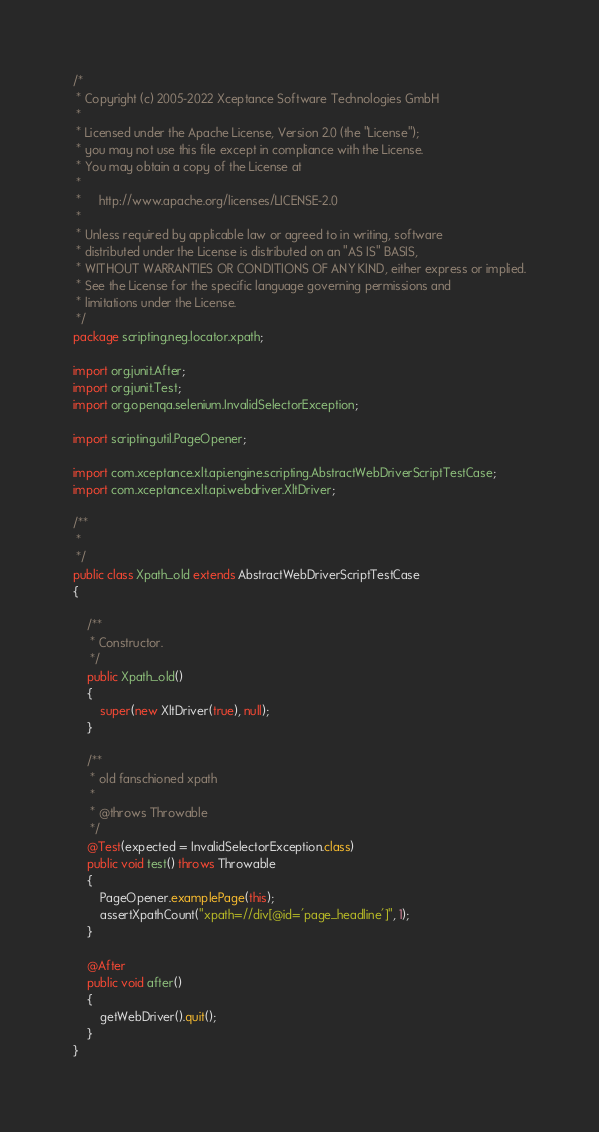<code> <loc_0><loc_0><loc_500><loc_500><_Java_>/*
 * Copyright (c) 2005-2022 Xceptance Software Technologies GmbH
 *
 * Licensed under the Apache License, Version 2.0 (the "License");
 * you may not use this file except in compliance with the License.
 * You may obtain a copy of the License at
 *
 *     http://www.apache.org/licenses/LICENSE-2.0
 *
 * Unless required by applicable law or agreed to in writing, software
 * distributed under the License is distributed on an "AS IS" BASIS,
 * WITHOUT WARRANTIES OR CONDITIONS OF ANY KIND, either express or implied.
 * See the License for the specific language governing permissions and
 * limitations under the License.
 */
package scripting.neg.locator.xpath;

import org.junit.After;
import org.junit.Test;
import org.openqa.selenium.InvalidSelectorException;

import scripting.util.PageOpener;

import com.xceptance.xlt.api.engine.scripting.AbstractWebDriverScriptTestCase;
import com.xceptance.xlt.api.webdriver.XltDriver;

/**
 * 
 */
public class Xpath_old extends AbstractWebDriverScriptTestCase
{

    /**
     * Constructor.
     */
    public Xpath_old()
    {
        super(new XltDriver(true), null);
    }

    /**
     * old fanschioned xpath
     * 
     * @throws Throwable
     */
    @Test(expected = InvalidSelectorException.class)
    public void test() throws Throwable
    {
        PageOpener.examplePage(this);
        assertXpathCount("xpath=//div[@id='page_headline']", 1);
    }

    @After
    public void after()
    {
        getWebDriver().quit();
    }
}</code> 